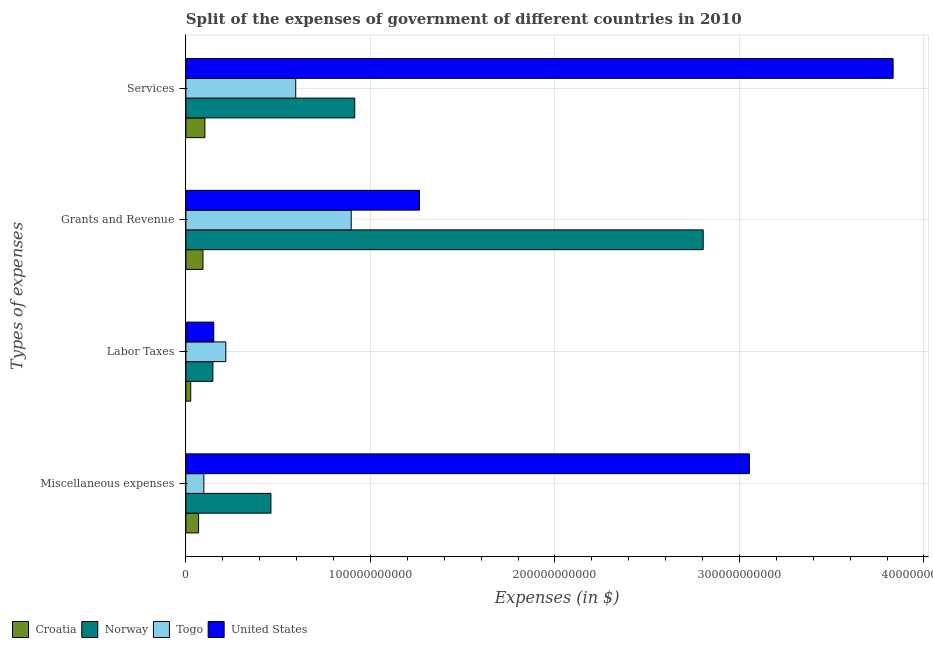How many groups of bars are there?
Keep it short and to the point. 4. Are the number of bars per tick equal to the number of legend labels?
Your response must be concise. Yes. How many bars are there on the 2nd tick from the top?
Make the answer very short. 4. How many bars are there on the 4th tick from the bottom?
Keep it short and to the point. 4. What is the label of the 1st group of bars from the top?
Provide a succinct answer. Services. What is the amount spent on services in Togo?
Your answer should be very brief. 5.95e+1. Across all countries, what is the maximum amount spent on services?
Offer a very short reply. 3.83e+11. Across all countries, what is the minimum amount spent on services?
Keep it short and to the point. 1.03e+1. In which country was the amount spent on services maximum?
Provide a short and direct response. United States. In which country was the amount spent on labor taxes minimum?
Provide a succinct answer. Croatia. What is the total amount spent on services in the graph?
Ensure brevity in your answer.  5.45e+11. What is the difference between the amount spent on services in Norway and that in Croatia?
Provide a short and direct response. 8.12e+1. What is the difference between the amount spent on grants and revenue in United States and the amount spent on labor taxes in Norway?
Make the answer very short. 1.12e+11. What is the average amount spent on services per country?
Keep it short and to the point. 1.36e+11. What is the difference between the amount spent on grants and revenue and amount spent on labor taxes in United States?
Your response must be concise. 1.12e+11. In how many countries, is the amount spent on miscellaneous expenses greater than 180000000000 $?
Your response must be concise. 1. What is the ratio of the amount spent on miscellaneous expenses in Norway to that in Togo?
Your answer should be very brief. 4.73. Is the amount spent on services in United States less than that in Norway?
Your answer should be very brief. No. Is the difference between the amount spent on miscellaneous expenses in Croatia and Togo greater than the difference between the amount spent on grants and revenue in Croatia and Togo?
Keep it short and to the point. Yes. What is the difference between the highest and the second highest amount spent on services?
Provide a succinct answer. 2.92e+11. What is the difference between the highest and the lowest amount spent on miscellaneous expenses?
Ensure brevity in your answer.  2.99e+11. In how many countries, is the amount spent on miscellaneous expenses greater than the average amount spent on miscellaneous expenses taken over all countries?
Offer a terse response. 1. Is the sum of the amount spent on miscellaneous expenses in United States and Togo greater than the maximum amount spent on grants and revenue across all countries?
Provide a succinct answer. Yes. What does the 4th bar from the top in Grants and Revenue represents?
Your answer should be very brief. Croatia. Are all the bars in the graph horizontal?
Keep it short and to the point. Yes. What is the difference between two consecutive major ticks on the X-axis?
Offer a terse response. 1.00e+11. Are the values on the major ticks of X-axis written in scientific E-notation?
Provide a short and direct response. No. Does the graph contain grids?
Your answer should be very brief. Yes. Where does the legend appear in the graph?
Offer a terse response. Bottom left. What is the title of the graph?
Provide a succinct answer. Split of the expenses of government of different countries in 2010. Does "Central Europe" appear as one of the legend labels in the graph?
Give a very brief answer. No. What is the label or title of the X-axis?
Provide a short and direct response. Expenses (in $). What is the label or title of the Y-axis?
Provide a succinct answer. Types of expenses. What is the Expenses (in $) of Croatia in Miscellaneous expenses?
Keep it short and to the point. 6.88e+09. What is the Expenses (in $) in Norway in Miscellaneous expenses?
Provide a succinct answer. 4.61e+1. What is the Expenses (in $) in Togo in Miscellaneous expenses?
Your response must be concise. 9.75e+09. What is the Expenses (in $) of United States in Miscellaneous expenses?
Provide a short and direct response. 3.05e+11. What is the Expenses (in $) in Croatia in Labor Taxes?
Give a very brief answer. 2.62e+09. What is the Expenses (in $) in Norway in Labor Taxes?
Provide a short and direct response. 1.46e+1. What is the Expenses (in $) of Togo in Labor Taxes?
Make the answer very short. 2.17e+1. What is the Expenses (in $) in United States in Labor Taxes?
Keep it short and to the point. 1.51e+1. What is the Expenses (in $) in Croatia in Grants and Revenue?
Provide a short and direct response. 9.26e+09. What is the Expenses (in $) in Norway in Grants and Revenue?
Ensure brevity in your answer.  2.80e+11. What is the Expenses (in $) of Togo in Grants and Revenue?
Ensure brevity in your answer.  8.96e+1. What is the Expenses (in $) of United States in Grants and Revenue?
Offer a very short reply. 1.27e+11. What is the Expenses (in $) of Croatia in Services?
Your response must be concise. 1.03e+1. What is the Expenses (in $) of Norway in Services?
Provide a succinct answer. 9.15e+1. What is the Expenses (in $) of Togo in Services?
Your response must be concise. 5.95e+1. What is the Expenses (in $) in United States in Services?
Provide a succinct answer. 3.83e+11. Across all Types of expenses, what is the maximum Expenses (in $) of Croatia?
Provide a short and direct response. 1.03e+1. Across all Types of expenses, what is the maximum Expenses (in $) in Norway?
Offer a terse response. 2.80e+11. Across all Types of expenses, what is the maximum Expenses (in $) in Togo?
Give a very brief answer. 8.96e+1. Across all Types of expenses, what is the maximum Expenses (in $) in United States?
Provide a short and direct response. 3.83e+11. Across all Types of expenses, what is the minimum Expenses (in $) in Croatia?
Your answer should be compact. 2.62e+09. Across all Types of expenses, what is the minimum Expenses (in $) in Norway?
Provide a succinct answer. 1.46e+1. Across all Types of expenses, what is the minimum Expenses (in $) in Togo?
Ensure brevity in your answer.  9.75e+09. Across all Types of expenses, what is the minimum Expenses (in $) in United States?
Keep it short and to the point. 1.51e+1. What is the total Expenses (in $) in Croatia in the graph?
Ensure brevity in your answer.  2.91e+1. What is the total Expenses (in $) of Norway in the graph?
Keep it short and to the point. 4.33e+11. What is the total Expenses (in $) of Togo in the graph?
Keep it short and to the point. 1.81e+11. What is the total Expenses (in $) in United States in the graph?
Your answer should be compact. 8.30e+11. What is the difference between the Expenses (in $) in Croatia in Miscellaneous expenses and that in Labor Taxes?
Provide a succinct answer. 4.26e+09. What is the difference between the Expenses (in $) in Norway in Miscellaneous expenses and that in Labor Taxes?
Keep it short and to the point. 3.14e+1. What is the difference between the Expenses (in $) of Togo in Miscellaneous expenses and that in Labor Taxes?
Provide a short and direct response. -1.19e+1. What is the difference between the Expenses (in $) in United States in Miscellaneous expenses and that in Labor Taxes?
Your answer should be very brief. 2.90e+11. What is the difference between the Expenses (in $) in Croatia in Miscellaneous expenses and that in Grants and Revenue?
Your answer should be compact. -2.38e+09. What is the difference between the Expenses (in $) of Norway in Miscellaneous expenses and that in Grants and Revenue?
Provide a short and direct response. -2.34e+11. What is the difference between the Expenses (in $) in Togo in Miscellaneous expenses and that in Grants and Revenue?
Provide a short and direct response. -7.99e+1. What is the difference between the Expenses (in $) in United States in Miscellaneous expenses and that in Grants and Revenue?
Ensure brevity in your answer.  1.79e+11. What is the difference between the Expenses (in $) in Croatia in Miscellaneous expenses and that in Services?
Offer a terse response. -3.42e+09. What is the difference between the Expenses (in $) in Norway in Miscellaneous expenses and that in Services?
Offer a very short reply. -4.54e+1. What is the difference between the Expenses (in $) in Togo in Miscellaneous expenses and that in Services?
Your answer should be compact. -4.98e+1. What is the difference between the Expenses (in $) of United States in Miscellaneous expenses and that in Services?
Your answer should be compact. -7.79e+1. What is the difference between the Expenses (in $) in Croatia in Labor Taxes and that in Grants and Revenue?
Your answer should be compact. -6.64e+09. What is the difference between the Expenses (in $) of Norway in Labor Taxes and that in Grants and Revenue?
Your answer should be very brief. -2.66e+11. What is the difference between the Expenses (in $) in Togo in Labor Taxes and that in Grants and Revenue?
Provide a succinct answer. -6.80e+1. What is the difference between the Expenses (in $) in United States in Labor Taxes and that in Grants and Revenue?
Your response must be concise. -1.12e+11. What is the difference between the Expenses (in $) in Croatia in Labor Taxes and that in Services?
Your response must be concise. -7.68e+09. What is the difference between the Expenses (in $) of Norway in Labor Taxes and that in Services?
Your response must be concise. -7.69e+1. What is the difference between the Expenses (in $) in Togo in Labor Taxes and that in Services?
Offer a terse response. -3.79e+1. What is the difference between the Expenses (in $) in United States in Labor Taxes and that in Services?
Make the answer very short. -3.68e+11. What is the difference between the Expenses (in $) in Croatia in Grants and Revenue and that in Services?
Your response must be concise. -1.04e+09. What is the difference between the Expenses (in $) of Norway in Grants and Revenue and that in Services?
Your answer should be very brief. 1.89e+11. What is the difference between the Expenses (in $) in Togo in Grants and Revenue and that in Services?
Ensure brevity in your answer.  3.01e+1. What is the difference between the Expenses (in $) of United States in Grants and Revenue and that in Services?
Offer a terse response. -2.57e+11. What is the difference between the Expenses (in $) of Croatia in Miscellaneous expenses and the Expenses (in $) of Norway in Labor Taxes?
Ensure brevity in your answer.  -7.77e+09. What is the difference between the Expenses (in $) of Croatia in Miscellaneous expenses and the Expenses (in $) of Togo in Labor Taxes?
Give a very brief answer. -1.48e+1. What is the difference between the Expenses (in $) of Croatia in Miscellaneous expenses and the Expenses (in $) of United States in Labor Taxes?
Offer a very short reply. -8.22e+09. What is the difference between the Expenses (in $) in Norway in Miscellaneous expenses and the Expenses (in $) in Togo in Labor Taxes?
Offer a terse response. 2.44e+1. What is the difference between the Expenses (in $) of Norway in Miscellaneous expenses and the Expenses (in $) of United States in Labor Taxes?
Offer a very short reply. 3.10e+1. What is the difference between the Expenses (in $) of Togo in Miscellaneous expenses and the Expenses (in $) of United States in Labor Taxes?
Offer a terse response. -5.35e+09. What is the difference between the Expenses (in $) in Croatia in Miscellaneous expenses and the Expenses (in $) in Norway in Grants and Revenue?
Make the answer very short. -2.73e+11. What is the difference between the Expenses (in $) of Croatia in Miscellaneous expenses and the Expenses (in $) of Togo in Grants and Revenue?
Give a very brief answer. -8.27e+1. What is the difference between the Expenses (in $) of Croatia in Miscellaneous expenses and the Expenses (in $) of United States in Grants and Revenue?
Give a very brief answer. -1.20e+11. What is the difference between the Expenses (in $) in Norway in Miscellaneous expenses and the Expenses (in $) in Togo in Grants and Revenue?
Your answer should be very brief. -4.35e+1. What is the difference between the Expenses (in $) of Norway in Miscellaneous expenses and the Expenses (in $) of United States in Grants and Revenue?
Make the answer very short. -8.05e+1. What is the difference between the Expenses (in $) in Togo in Miscellaneous expenses and the Expenses (in $) in United States in Grants and Revenue?
Provide a succinct answer. -1.17e+11. What is the difference between the Expenses (in $) in Croatia in Miscellaneous expenses and the Expenses (in $) in Norway in Services?
Offer a terse response. -8.46e+1. What is the difference between the Expenses (in $) in Croatia in Miscellaneous expenses and the Expenses (in $) in Togo in Services?
Provide a short and direct response. -5.27e+1. What is the difference between the Expenses (in $) of Croatia in Miscellaneous expenses and the Expenses (in $) of United States in Services?
Provide a succinct answer. -3.76e+11. What is the difference between the Expenses (in $) of Norway in Miscellaneous expenses and the Expenses (in $) of Togo in Services?
Offer a terse response. -1.34e+1. What is the difference between the Expenses (in $) in Norway in Miscellaneous expenses and the Expenses (in $) in United States in Services?
Offer a very short reply. -3.37e+11. What is the difference between the Expenses (in $) of Togo in Miscellaneous expenses and the Expenses (in $) of United States in Services?
Provide a succinct answer. -3.74e+11. What is the difference between the Expenses (in $) in Croatia in Labor Taxes and the Expenses (in $) in Norway in Grants and Revenue?
Your answer should be compact. -2.78e+11. What is the difference between the Expenses (in $) of Croatia in Labor Taxes and the Expenses (in $) of Togo in Grants and Revenue?
Keep it short and to the point. -8.70e+1. What is the difference between the Expenses (in $) in Croatia in Labor Taxes and the Expenses (in $) in United States in Grants and Revenue?
Provide a short and direct response. -1.24e+11. What is the difference between the Expenses (in $) in Norway in Labor Taxes and the Expenses (in $) in Togo in Grants and Revenue?
Ensure brevity in your answer.  -7.50e+1. What is the difference between the Expenses (in $) of Norway in Labor Taxes and the Expenses (in $) of United States in Grants and Revenue?
Your answer should be very brief. -1.12e+11. What is the difference between the Expenses (in $) in Togo in Labor Taxes and the Expenses (in $) in United States in Grants and Revenue?
Offer a very short reply. -1.05e+11. What is the difference between the Expenses (in $) of Croatia in Labor Taxes and the Expenses (in $) of Norway in Services?
Keep it short and to the point. -8.89e+1. What is the difference between the Expenses (in $) in Croatia in Labor Taxes and the Expenses (in $) in Togo in Services?
Provide a short and direct response. -5.69e+1. What is the difference between the Expenses (in $) of Croatia in Labor Taxes and the Expenses (in $) of United States in Services?
Your answer should be very brief. -3.81e+11. What is the difference between the Expenses (in $) in Norway in Labor Taxes and the Expenses (in $) in Togo in Services?
Your answer should be compact. -4.49e+1. What is the difference between the Expenses (in $) of Norway in Labor Taxes and the Expenses (in $) of United States in Services?
Provide a succinct answer. -3.69e+11. What is the difference between the Expenses (in $) in Togo in Labor Taxes and the Expenses (in $) in United States in Services?
Your answer should be compact. -3.62e+11. What is the difference between the Expenses (in $) in Croatia in Grants and Revenue and the Expenses (in $) in Norway in Services?
Your answer should be compact. -8.23e+1. What is the difference between the Expenses (in $) of Croatia in Grants and Revenue and the Expenses (in $) of Togo in Services?
Offer a very short reply. -5.03e+1. What is the difference between the Expenses (in $) of Croatia in Grants and Revenue and the Expenses (in $) of United States in Services?
Your response must be concise. -3.74e+11. What is the difference between the Expenses (in $) of Norway in Grants and Revenue and the Expenses (in $) of Togo in Services?
Provide a short and direct response. 2.21e+11. What is the difference between the Expenses (in $) in Norway in Grants and Revenue and the Expenses (in $) in United States in Services?
Keep it short and to the point. -1.03e+11. What is the difference between the Expenses (in $) in Togo in Grants and Revenue and the Expenses (in $) in United States in Services?
Give a very brief answer. -2.94e+11. What is the average Expenses (in $) of Croatia per Types of expenses?
Your response must be concise. 7.27e+09. What is the average Expenses (in $) in Norway per Types of expenses?
Offer a very short reply. 1.08e+11. What is the average Expenses (in $) in Togo per Types of expenses?
Offer a terse response. 4.51e+1. What is the average Expenses (in $) in United States per Types of expenses?
Offer a very short reply. 2.08e+11. What is the difference between the Expenses (in $) in Croatia and Expenses (in $) in Norway in Miscellaneous expenses?
Provide a short and direct response. -3.92e+1. What is the difference between the Expenses (in $) of Croatia and Expenses (in $) of Togo in Miscellaneous expenses?
Make the answer very short. -2.86e+09. What is the difference between the Expenses (in $) in Croatia and Expenses (in $) in United States in Miscellaneous expenses?
Your response must be concise. -2.99e+11. What is the difference between the Expenses (in $) in Norway and Expenses (in $) in Togo in Miscellaneous expenses?
Provide a short and direct response. 3.63e+1. What is the difference between the Expenses (in $) of Norway and Expenses (in $) of United States in Miscellaneous expenses?
Offer a terse response. -2.59e+11. What is the difference between the Expenses (in $) of Togo and Expenses (in $) of United States in Miscellaneous expenses?
Offer a very short reply. -2.96e+11. What is the difference between the Expenses (in $) of Croatia and Expenses (in $) of Norway in Labor Taxes?
Ensure brevity in your answer.  -1.20e+1. What is the difference between the Expenses (in $) in Croatia and Expenses (in $) in Togo in Labor Taxes?
Offer a terse response. -1.90e+1. What is the difference between the Expenses (in $) of Croatia and Expenses (in $) of United States in Labor Taxes?
Ensure brevity in your answer.  -1.25e+1. What is the difference between the Expenses (in $) of Norway and Expenses (in $) of Togo in Labor Taxes?
Keep it short and to the point. -7.00e+09. What is the difference between the Expenses (in $) in Norway and Expenses (in $) in United States in Labor Taxes?
Make the answer very short. -4.50e+08. What is the difference between the Expenses (in $) of Togo and Expenses (in $) of United States in Labor Taxes?
Keep it short and to the point. 6.55e+09. What is the difference between the Expenses (in $) of Croatia and Expenses (in $) of Norway in Grants and Revenue?
Your response must be concise. -2.71e+11. What is the difference between the Expenses (in $) of Croatia and Expenses (in $) of Togo in Grants and Revenue?
Ensure brevity in your answer.  -8.03e+1. What is the difference between the Expenses (in $) of Croatia and Expenses (in $) of United States in Grants and Revenue?
Offer a terse response. -1.17e+11. What is the difference between the Expenses (in $) of Norway and Expenses (in $) of Togo in Grants and Revenue?
Your answer should be compact. 1.91e+11. What is the difference between the Expenses (in $) of Norway and Expenses (in $) of United States in Grants and Revenue?
Offer a very short reply. 1.54e+11. What is the difference between the Expenses (in $) in Togo and Expenses (in $) in United States in Grants and Revenue?
Your response must be concise. -3.70e+1. What is the difference between the Expenses (in $) in Croatia and Expenses (in $) in Norway in Services?
Your response must be concise. -8.12e+1. What is the difference between the Expenses (in $) of Croatia and Expenses (in $) of Togo in Services?
Provide a short and direct response. -4.92e+1. What is the difference between the Expenses (in $) of Croatia and Expenses (in $) of United States in Services?
Keep it short and to the point. -3.73e+11. What is the difference between the Expenses (in $) of Norway and Expenses (in $) of Togo in Services?
Your response must be concise. 3.20e+1. What is the difference between the Expenses (in $) of Norway and Expenses (in $) of United States in Services?
Give a very brief answer. -2.92e+11. What is the difference between the Expenses (in $) in Togo and Expenses (in $) in United States in Services?
Give a very brief answer. -3.24e+11. What is the ratio of the Expenses (in $) of Croatia in Miscellaneous expenses to that in Labor Taxes?
Keep it short and to the point. 2.62. What is the ratio of the Expenses (in $) of Norway in Miscellaneous expenses to that in Labor Taxes?
Ensure brevity in your answer.  3.15. What is the ratio of the Expenses (in $) in Togo in Miscellaneous expenses to that in Labor Taxes?
Your response must be concise. 0.45. What is the ratio of the Expenses (in $) in United States in Miscellaneous expenses to that in Labor Taxes?
Offer a terse response. 20.23. What is the ratio of the Expenses (in $) of Croatia in Miscellaneous expenses to that in Grants and Revenue?
Your response must be concise. 0.74. What is the ratio of the Expenses (in $) in Norway in Miscellaneous expenses to that in Grants and Revenue?
Provide a short and direct response. 0.16. What is the ratio of the Expenses (in $) of Togo in Miscellaneous expenses to that in Grants and Revenue?
Give a very brief answer. 0.11. What is the ratio of the Expenses (in $) in United States in Miscellaneous expenses to that in Grants and Revenue?
Provide a short and direct response. 2.41. What is the ratio of the Expenses (in $) in Croatia in Miscellaneous expenses to that in Services?
Your response must be concise. 0.67. What is the ratio of the Expenses (in $) in Norway in Miscellaneous expenses to that in Services?
Provide a succinct answer. 0.5. What is the ratio of the Expenses (in $) in Togo in Miscellaneous expenses to that in Services?
Provide a succinct answer. 0.16. What is the ratio of the Expenses (in $) of United States in Miscellaneous expenses to that in Services?
Your answer should be very brief. 0.8. What is the ratio of the Expenses (in $) in Croatia in Labor Taxes to that in Grants and Revenue?
Make the answer very short. 0.28. What is the ratio of the Expenses (in $) of Norway in Labor Taxes to that in Grants and Revenue?
Offer a very short reply. 0.05. What is the ratio of the Expenses (in $) in Togo in Labor Taxes to that in Grants and Revenue?
Offer a terse response. 0.24. What is the ratio of the Expenses (in $) of United States in Labor Taxes to that in Grants and Revenue?
Give a very brief answer. 0.12. What is the ratio of the Expenses (in $) of Croatia in Labor Taxes to that in Services?
Ensure brevity in your answer.  0.25. What is the ratio of the Expenses (in $) in Norway in Labor Taxes to that in Services?
Offer a very short reply. 0.16. What is the ratio of the Expenses (in $) of Togo in Labor Taxes to that in Services?
Provide a short and direct response. 0.36. What is the ratio of the Expenses (in $) in United States in Labor Taxes to that in Services?
Give a very brief answer. 0.04. What is the ratio of the Expenses (in $) in Croatia in Grants and Revenue to that in Services?
Offer a terse response. 0.9. What is the ratio of the Expenses (in $) of Norway in Grants and Revenue to that in Services?
Your answer should be very brief. 3.06. What is the ratio of the Expenses (in $) in Togo in Grants and Revenue to that in Services?
Offer a terse response. 1.51. What is the ratio of the Expenses (in $) of United States in Grants and Revenue to that in Services?
Offer a very short reply. 0.33. What is the difference between the highest and the second highest Expenses (in $) in Croatia?
Offer a very short reply. 1.04e+09. What is the difference between the highest and the second highest Expenses (in $) of Norway?
Your answer should be compact. 1.89e+11. What is the difference between the highest and the second highest Expenses (in $) in Togo?
Ensure brevity in your answer.  3.01e+1. What is the difference between the highest and the second highest Expenses (in $) in United States?
Your response must be concise. 7.79e+1. What is the difference between the highest and the lowest Expenses (in $) of Croatia?
Your response must be concise. 7.68e+09. What is the difference between the highest and the lowest Expenses (in $) of Norway?
Ensure brevity in your answer.  2.66e+11. What is the difference between the highest and the lowest Expenses (in $) in Togo?
Your answer should be compact. 7.99e+1. What is the difference between the highest and the lowest Expenses (in $) in United States?
Your answer should be compact. 3.68e+11. 